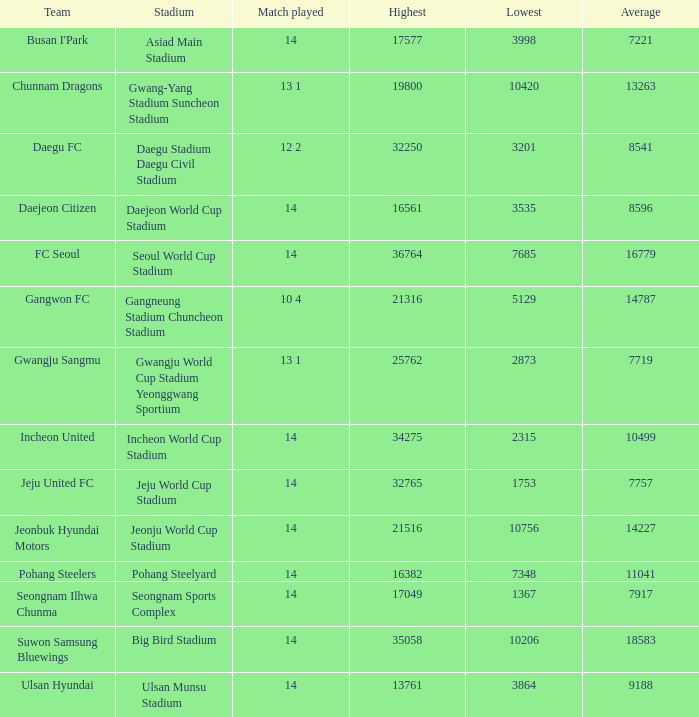What is the highest when pohang steelers is the team? 16382.0. 